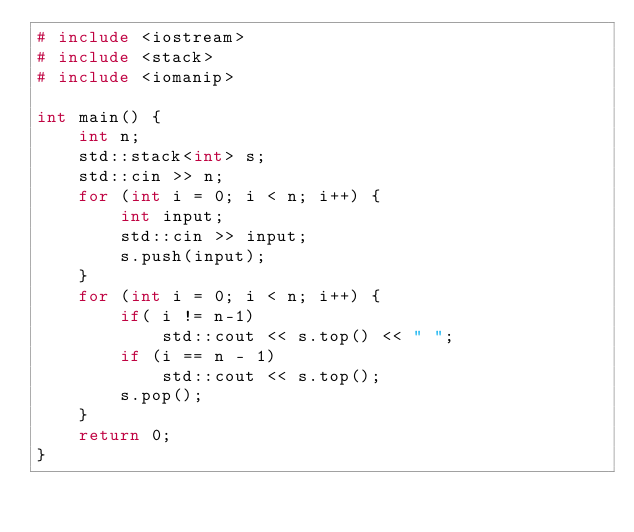<code> <loc_0><loc_0><loc_500><loc_500><_C++_># include <iostream>
# include <stack>
# include <iomanip>

int main() {
	int n;
	std::stack<int> s;
	std::cin >> n;
	for (int i = 0; i < n; i++) {
		int input;
		std::cin >> input;
		s.push(input);
	}
	for (int i = 0; i < n; i++) {
		if( i != n-1)
			std::cout << s.top() << " ";
		if (i == n - 1)
			std::cout << s.top();
		s.pop();
	}
	return 0;
}</code> 